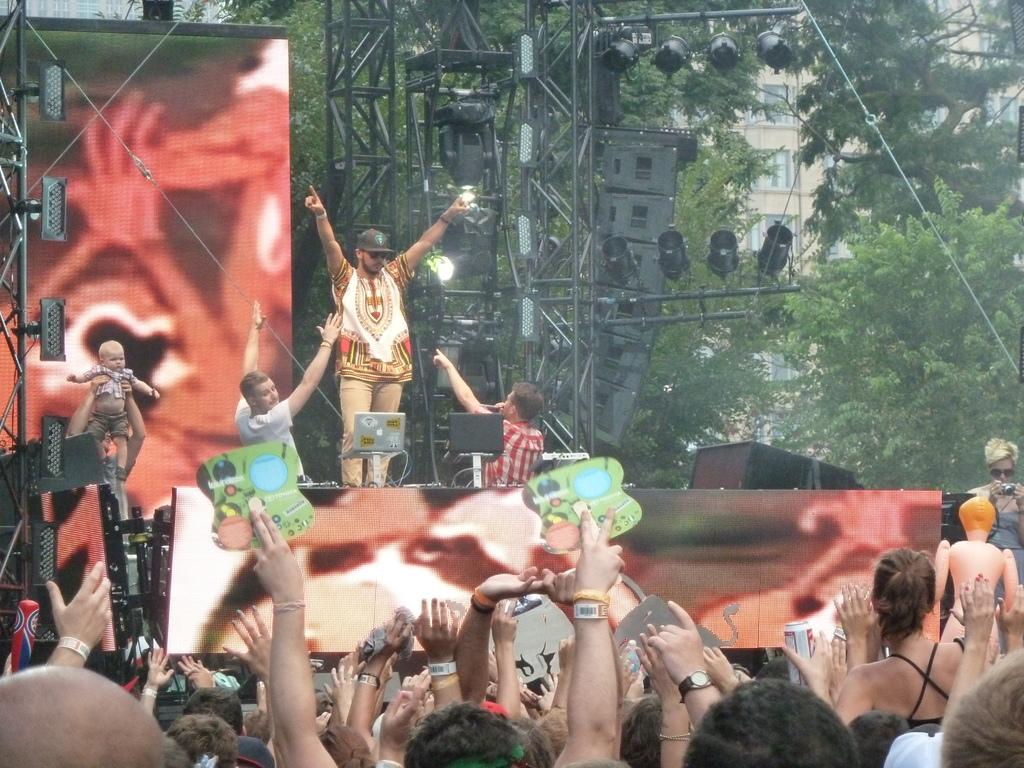What are the people in the image doing? The people are standing on a dais in the image. Who is present in the image besides the people on the dais? There is an audience in the image. What can be seen on the right side of the image? There are trees on the right side of the image. What is visible in the background of the image? There is a building in the backdrop of the image. What type of oatmeal is being served to the pet in the image? There is no pet or oatmeal present in the image. 